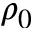<formula> <loc_0><loc_0><loc_500><loc_500>\rho _ { 0 }</formula> 